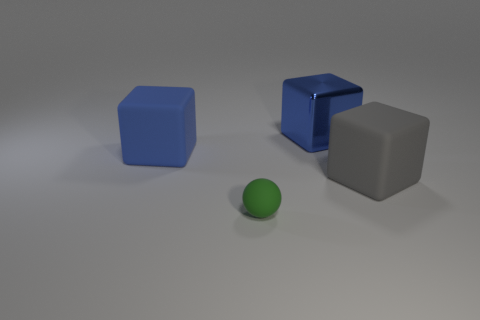What is the size of the other thing that is the same color as the large metallic thing?
Offer a very short reply. Large. Are there more metallic cubes than big cubes?
Provide a succinct answer. No. What number of green matte balls are the same size as the gray matte block?
Offer a very short reply. 0. What number of things are either large blue cubes to the right of the small green object or cyan matte objects?
Ensure brevity in your answer.  1. Are there fewer big blue metallic things than tiny purple matte cubes?
Offer a terse response. No. There is a tiny green thing that is made of the same material as the large gray cube; what shape is it?
Your answer should be compact. Sphere. There is a large metal cube; are there any large blue shiny things on the left side of it?
Offer a very short reply. No. Is the number of large blue things in front of the rubber ball less than the number of tiny cyan rubber objects?
Offer a very short reply. No. What is the big gray block made of?
Offer a terse response. Rubber. What color is the tiny thing?
Offer a terse response. Green. 